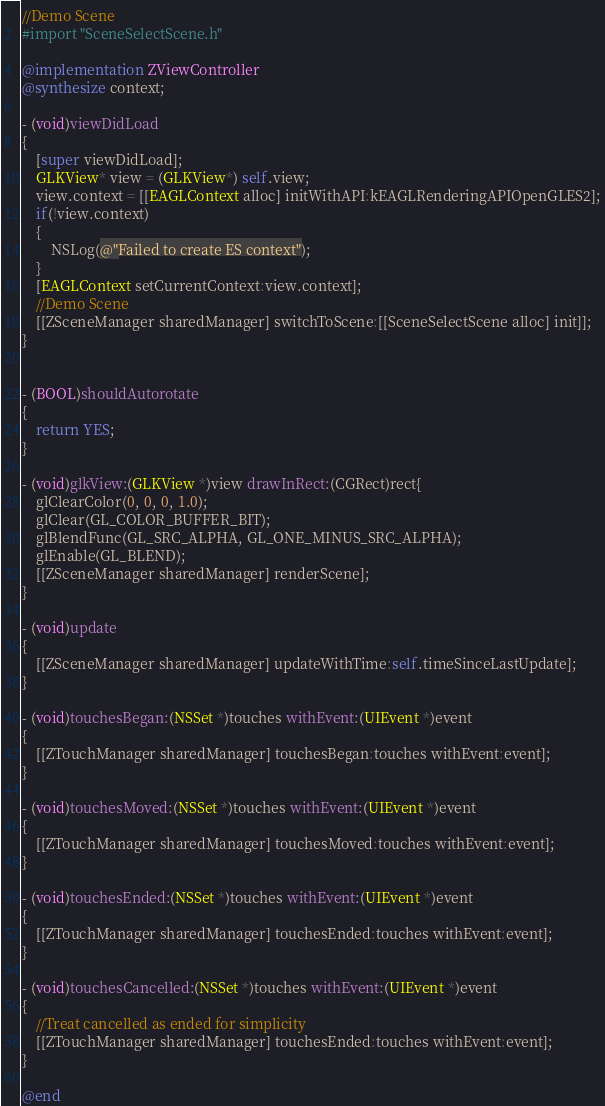Convert code to text. <code><loc_0><loc_0><loc_500><loc_500><_ObjectiveC_>//Demo Scene
#import "SceneSelectScene.h"

@implementation ZViewController
@synthesize context;

- (void)viewDidLoad
{
    [super viewDidLoad];
    GLKView* view = (GLKView*) self.view;
    view.context = [[EAGLContext alloc] initWithAPI:kEAGLRenderingAPIOpenGLES2];
    if(!view.context)
    {
        NSLog(@"Failed to create ES context");
    }
    [EAGLContext setCurrentContext:view.context];
    //Demo Scene
    [[ZSceneManager sharedManager] switchToScene:[[SceneSelectScene alloc] init]];
}


- (BOOL)shouldAutorotate
{
    return YES;
}

- (void)glkView:(GLKView *)view drawInRect:(CGRect)rect{
    glClearColor(0, 0, 0, 1.0);
    glClear(GL_COLOR_BUFFER_BIT);
    glBlendFunc(GL_SRC_ALPHA, GL_ONE_MINUS_SRC_ALPHA);
    glEnable(GL_BLEND);
    [[ZSceneManager sharedManager] renderScene];
}

- (void)update
{
    [[ZSceneManager sharedManager] updateWithTime:self.timeSinceLastUpdate];
}

- (void)touchesBegan:(NSSet *)touches withEvent:(UIEvent *)event
{
    [[ZTouchManager sharedManager] touchesBegan:touches withEvent:event];
}

- (void)touchesMoved:(NSSet *)touches withEvent:(UIEvent *)event
{
    [[ZTouchManager sharedManager] touchesMoved:touches withEvent:event];
}

- (void)touchesEnded:(NSSet *)touches withEvent:(UIEvent *)event
{
    [[ZTouchManager sharedManager] touchesEnded:touches withEvent:event];
}

- (void)touchesCancelled:(NSSet *)touches withEvent:(UIEvent *)event
{
    //Treat cancelled as ended for simplicity
    [[ZTouchManager sharedManager] touchesEnded:touches withEvent:event];
}

@end
</code> 